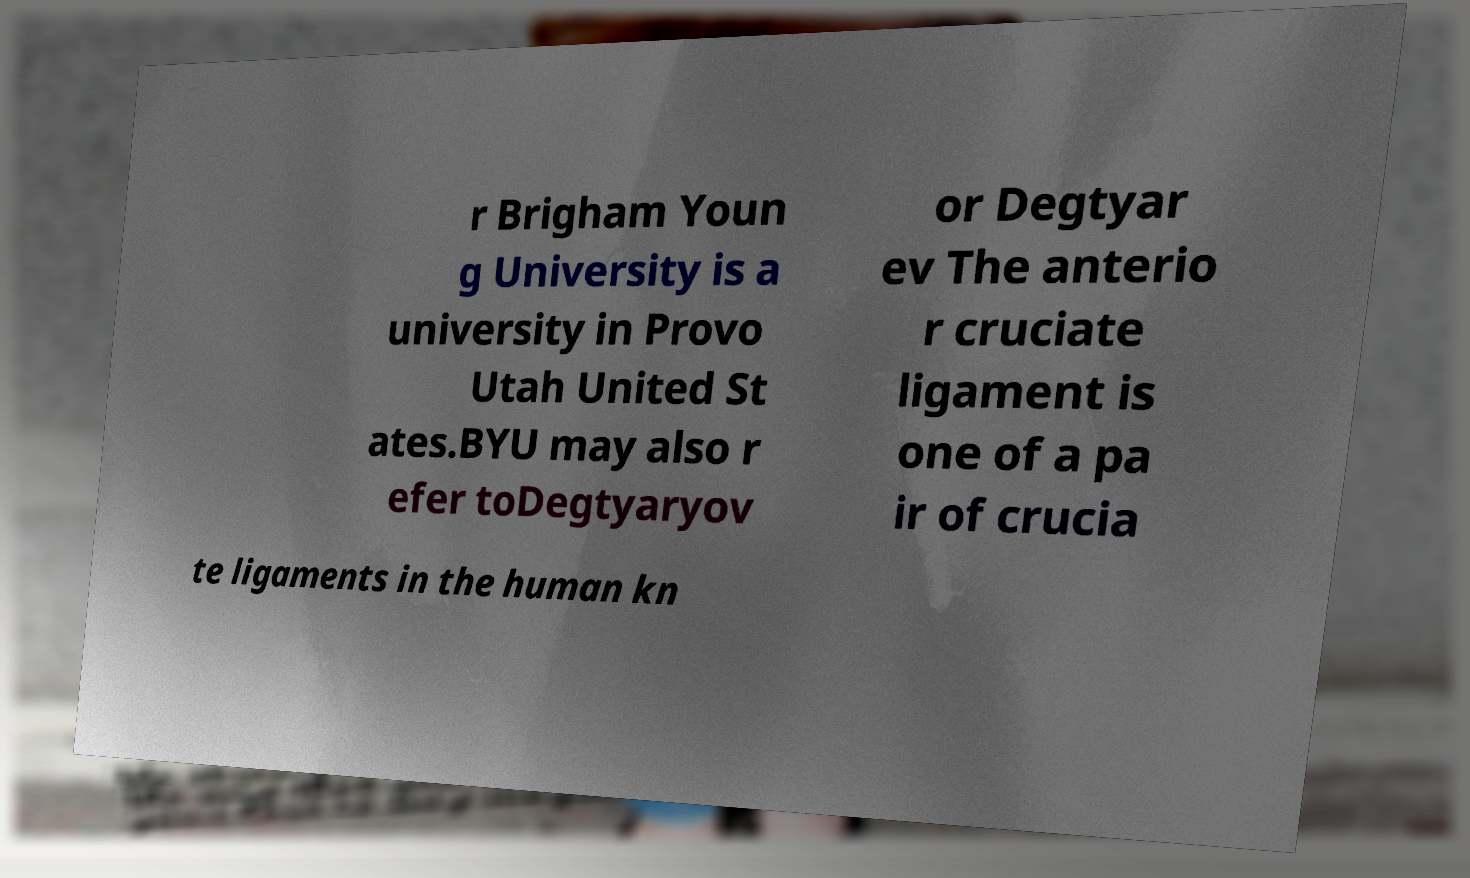There's text embedded in this image that I need extracted. Can you transcribe it verbatim? r Brigham Youn g University is a university in Provo Utah United St ates.BYU may also r efer toDegtyaryov or Degtyar ev The anterio r cruciate ligament is one of a pa ir of crucia te ligaments in the human kn 